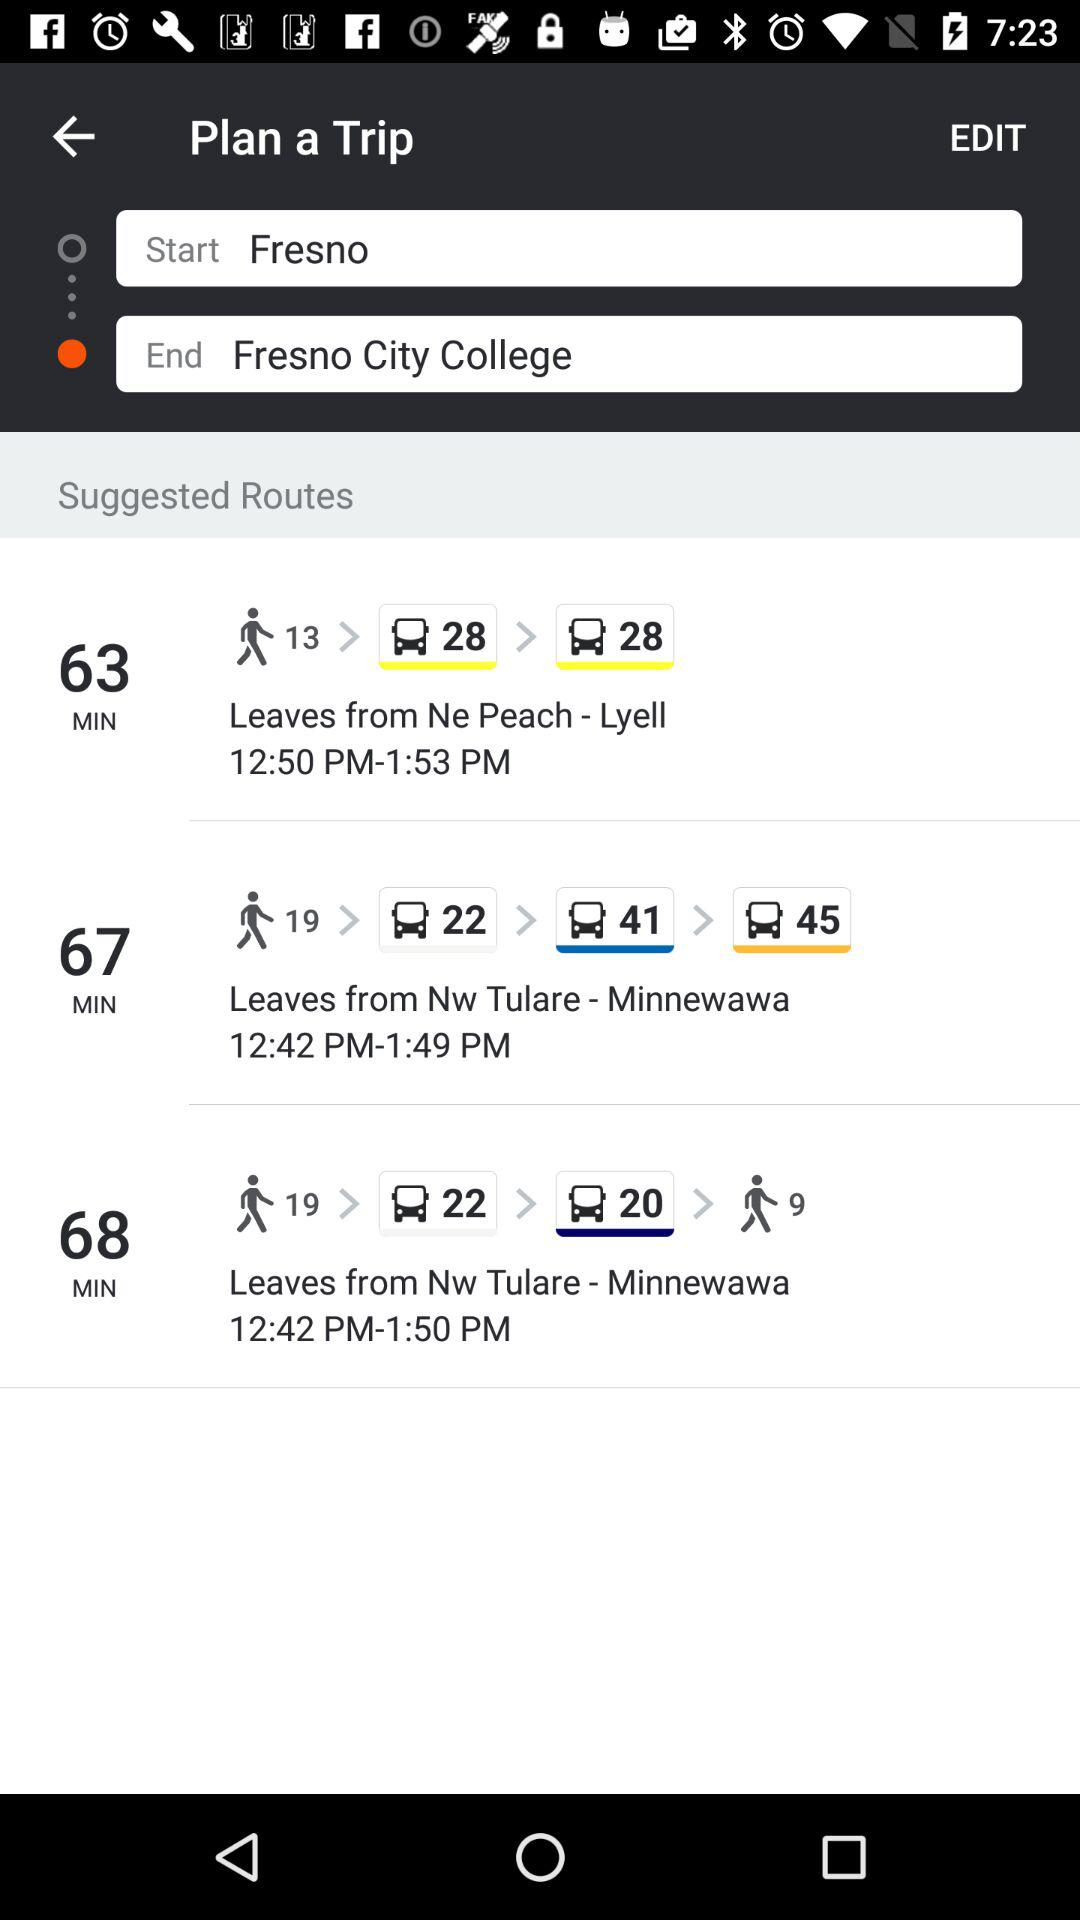What is the ending location? The ending location is Fresno City College. 